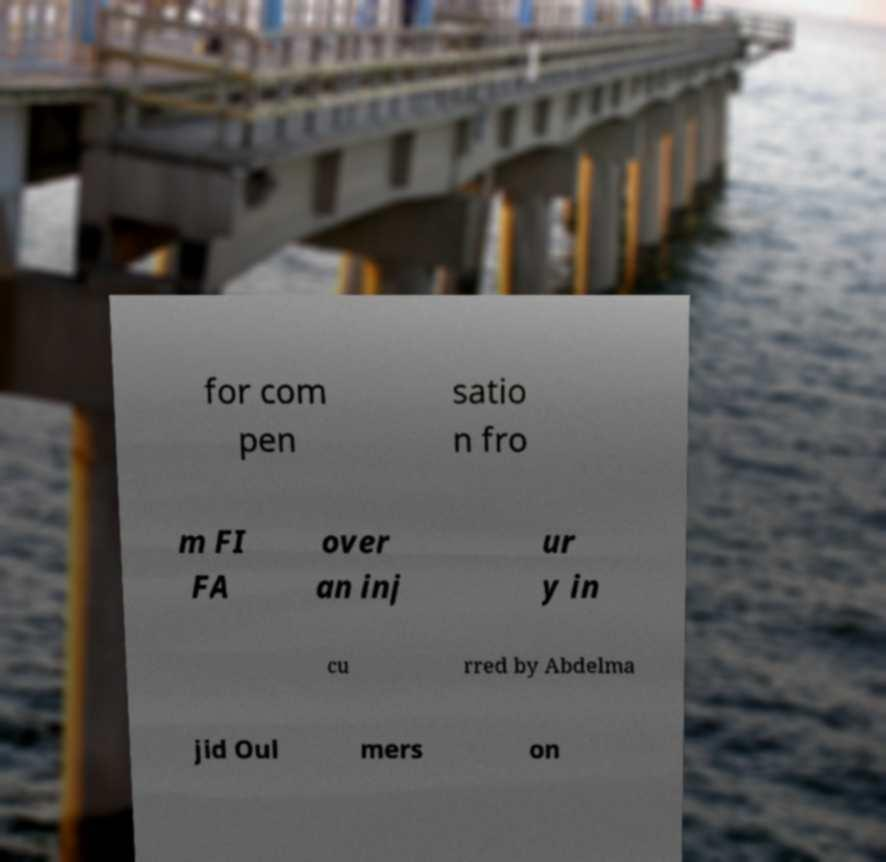For documentation purposes, I need the text within this image transcribed. Could you provide that? for com pen satio n fro m FI FA over an inj ur y in cu rred by Abdelma jid Oul mers on 